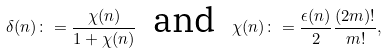<formula> <loc_0><loc_0><loc_500><loc_500>\delta ( n ) \colon = \frac { \chi ( n ) } { 1 + \chi ( n ) } \ \text { and } \ \chi ( n ) \colon = \frac { \epsilon ( n ) } { 2 } \frac { ( 2 m ) ! } { m ! } ,</formula> 